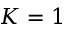<formula> <loc_0><loc_0><loc_500><loc_500>K = 1</formula> 